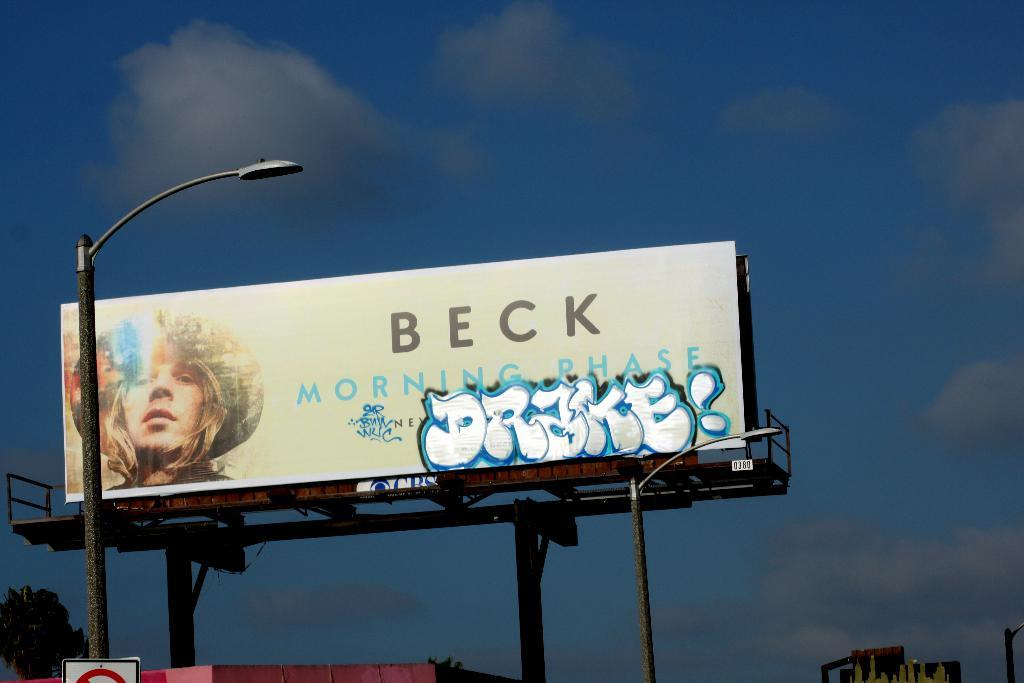<image>
Write a terse but informative summary of the picture. A Beck Morning Show billboard with the graffiti word DRAKE! on it. 